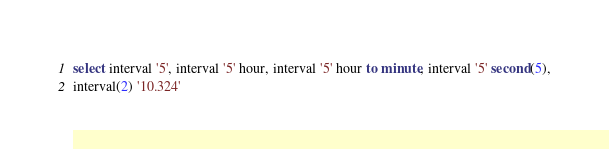Convert code to text. <code><loc_0><loc_0><loc_500><loc_500><_SQL_>select interval '5', interval '5' hour, interval '5' hour to minute, interval '5' second(5),
interval(2) '10.324'
</code> 